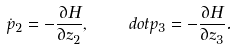Convert formula to latex. <formula><loc_0><loc_0><loc_500><loc_500>\dot { p } _ { 2 } = - \frac { \partial H } { \partial z _ { 2 } } , \quad d o t p _ { 3 } = - \frac { \partial H } { \partial z _ { 3 } } .</formula> 